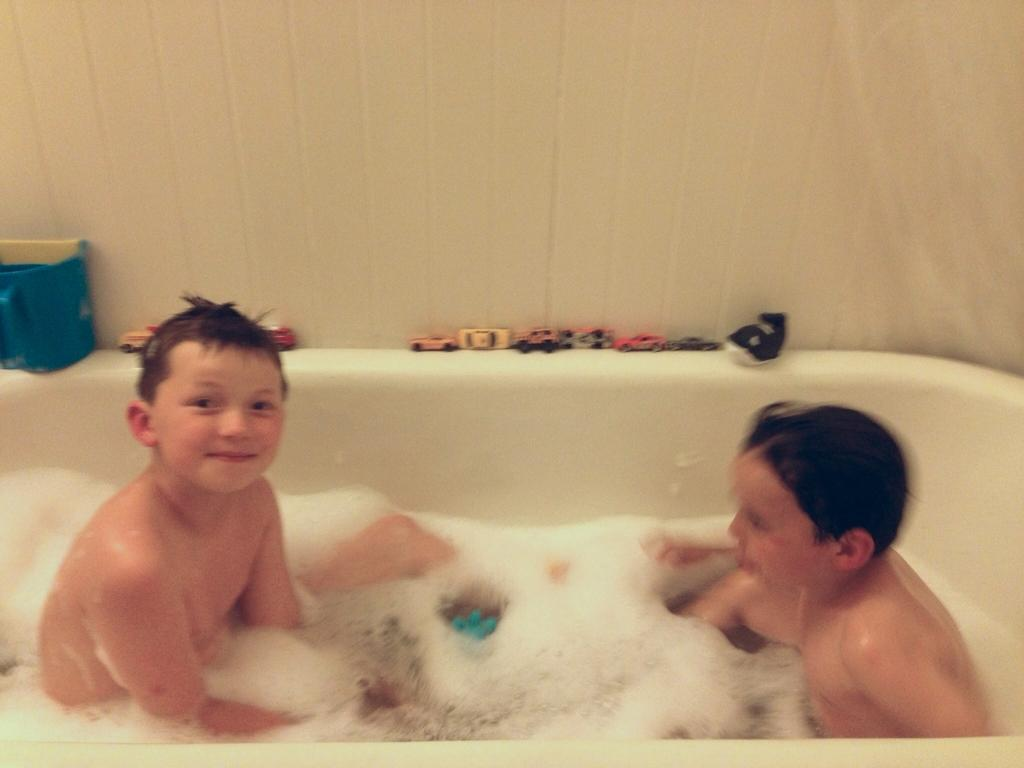How many boys are in the image? There are two boys in the image. What are the boys doing in the image? The boys are sitting in a bath tub. What can be found in the bath tub with the boys? There is water, foam, playing cards, and a mug in the bath tub. What is visible in the background of the image? There is a wall visible in the image. What type of fuel is being used to heat the water in the bath tub? There is no mention of fuel in the image; it only shows the boys, water, foam, playing cards, and a mug in the bath tub. 